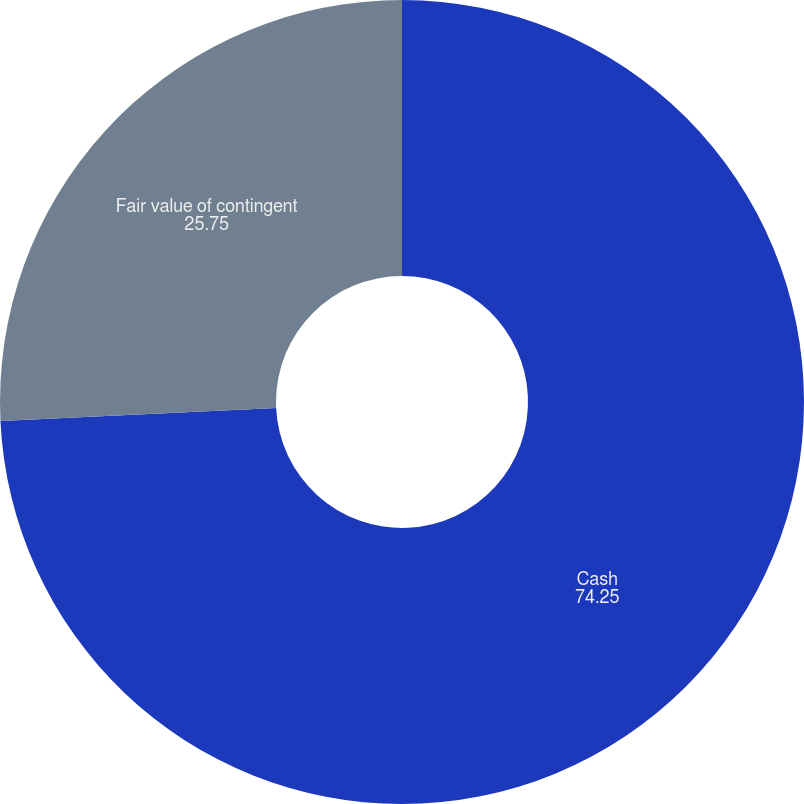<chart> <loc_0><loc_0><loc_500><loc_500><pie_chart><fcel>Cash<fcel>Fair value of contingent<nl><fcel>74.25%<fcel>25.75%<nl></chart> 